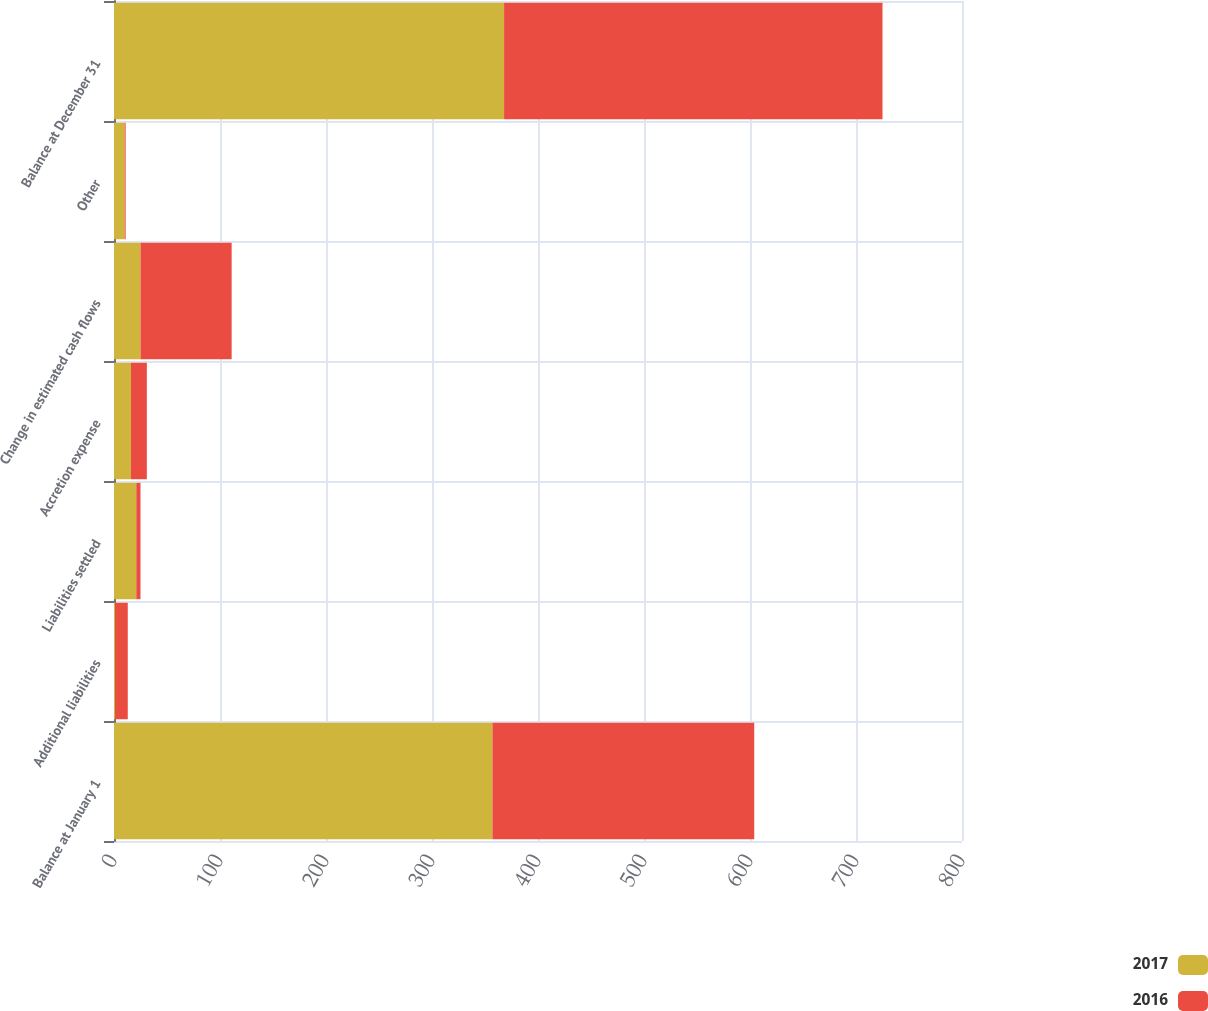Convert chart to OTSL. <chart><loc_0><loc_0><loc_500><loc_500><stacked_bar_chart><ecel><fcel>Balance at January 1<fcel>Additional liabilities<fcel>Liabilities settled<fcel>Accretion expense<fcel>Change in estimated cash flows<fcel>Other<fcel>Balance at December 31<nl><fcel>2017<fcel>357<fcel>1<fcel>21<fcel>16<fcel>25<fcel>10<fcel>368<nl><fcel>2016<fcel>247<fcel>12<fcel>4<fcel>15<fcel>86<fcel>1<fcel>357<nl></chart> 